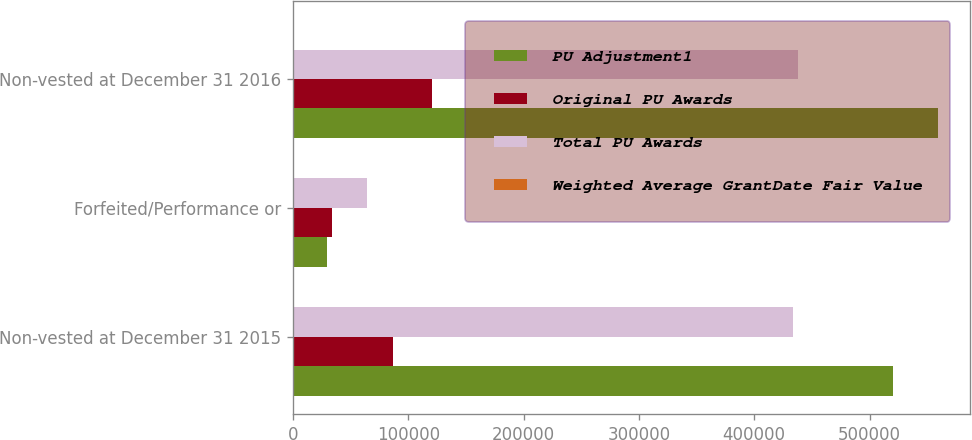Convert chart to OTSL. <chart><loc_0><loc_0><loc_500><loc_500><stacked_bar_chart><ecel><fcel>Non-vested at December 31 2015<fcel>Forfeited/Performance or<fcel>Non-vested at December 31 2016<nl><fcel>PU Adjustment1<fcel>520764<fcel>29920<fcel>559340<nl><fcel>Original PU Awards<fcel>86959<fcel>34079<fcel>121038<nl><fcel>Total PU Awards<fcel>433805<fcel>63999<fcel>438302<nl><fcel>Weighted Average GrantDate Fair Value<fcel>34.11<fcel>40.98<fcel>33.67<nl></chart> 